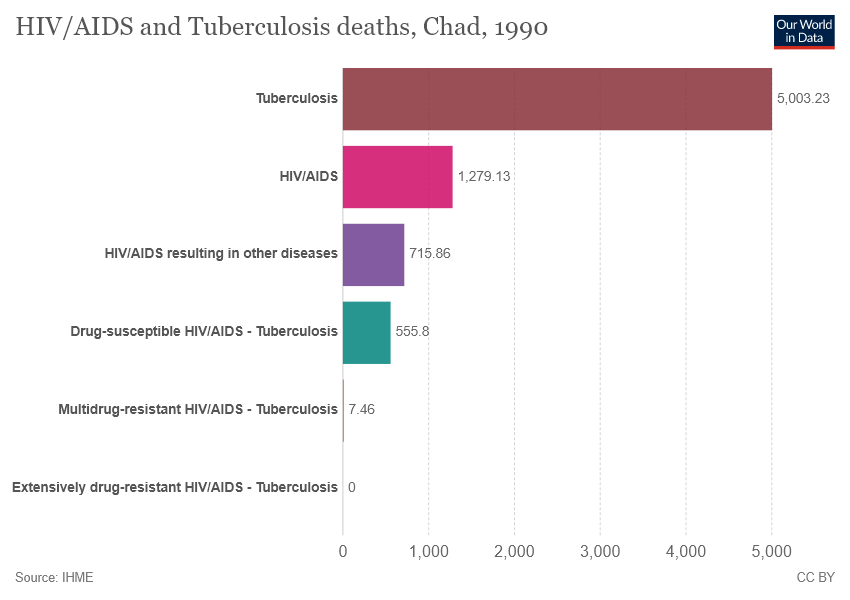Highlight a few significant elements in this photo. HIV/AIDS is represented by a pink color bar. The average number of deaths due to Tuberculosis and HIV/AIDS is 3141.18. 